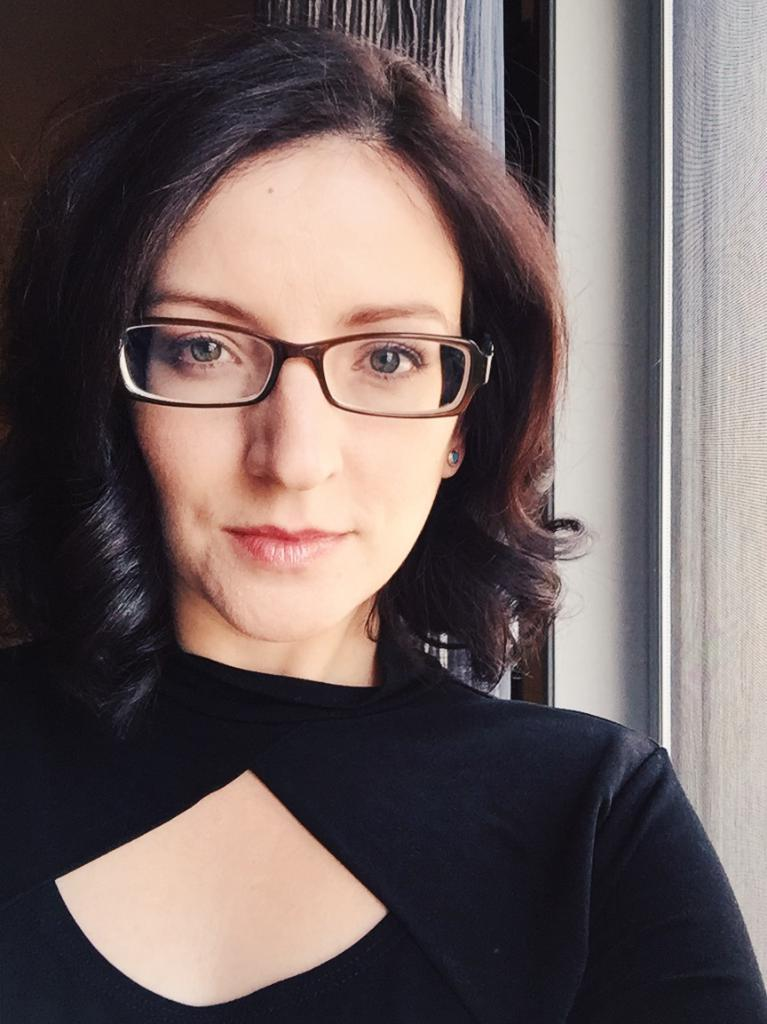Who is present in the image? There is a woman in the image. What is the woman doing in the image? The woman is standing in the image. What is the woman's facial expression in the image? The woman is smiling in the image. What can be seen in the background of the image? There is a curtain and a wall in the background of the image. How many snails are crawling on the woman's shoulder in the image? There are no snails present in the image. What type of cake is being served for the woman's birthday in the image? There is no birthday celebration or cake present in the image. 